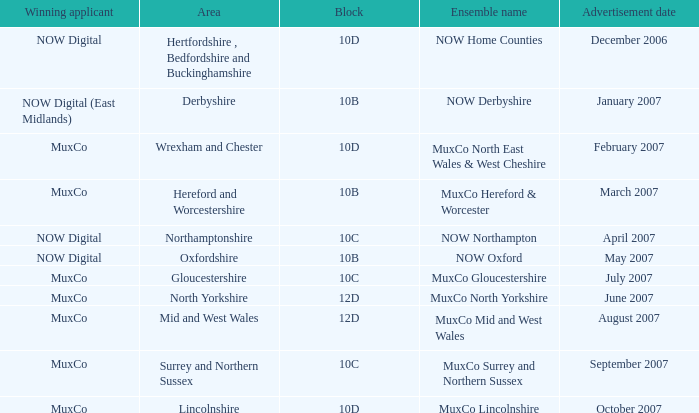What is Ensemble Name Muxco Gloucestershire's Advertisement Date in Block 10C? July 2007. 